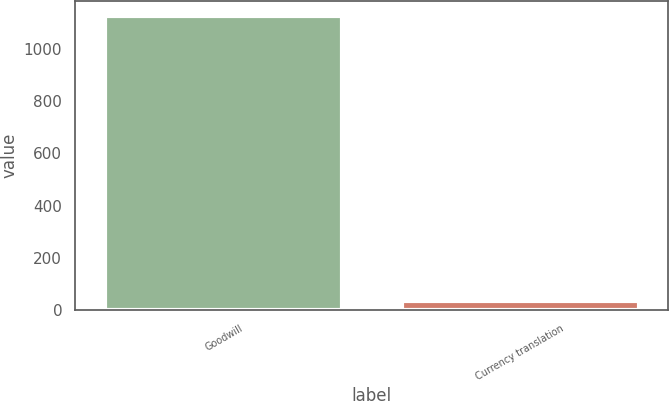Convert chart. <chart><loc_0><loc_0><loc_500><loc_500><bar_chart><fcel>Goodwill<fcel>Currency translation<nl><fcel>1128.6<fcel>34.5<nl></chart> 